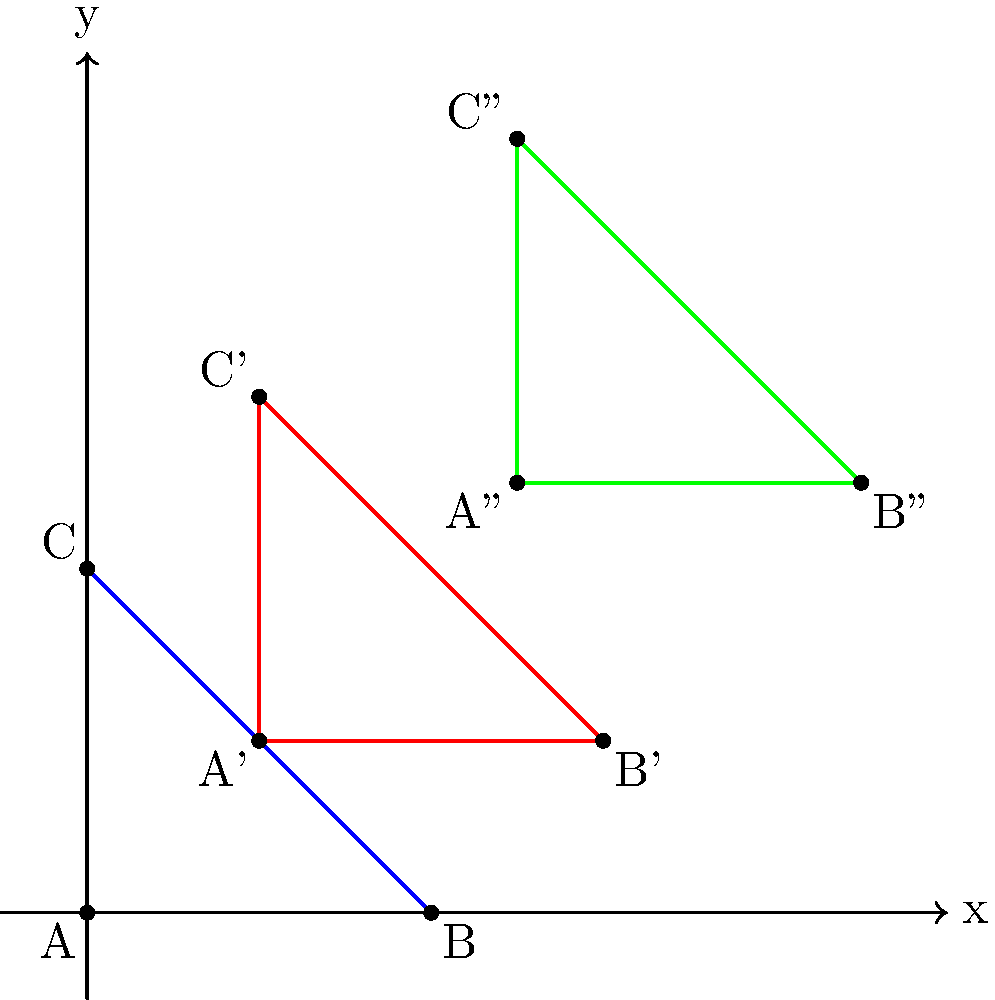On a battlefield map, a unit's position is represented by triangle ABC. The unit undergoes two consecutive transformations: first, a translation of (2,2), followed by a rotation of 90° clockwise around the point (2,2). What are the coordinates of point C after these transformations? Let's approach this step-by-step:

1) Initial position: Triangle ABC has vertices A(0,0), B(4,0), and C(0,4).

2) First transformation - Translation by (2,2):
   - A'(2,2), B'(6,2), C'(2,6)
   This is represented by the red triangle in the diagram.

3) Second transformation - 90° clockwise rotation around (2,2):
   - To rotate a point (x,y) 90° clockwise around (a,b), we use the formula:
     $$(x',y') = (a + (y-b), b - (x-a))$$
   
   - For point C'(2,6), we have:
     $$x'' = 2 + (6-2) = 2 + 4 = 6$$
     $$y'' = 2 - (2-2) = 2 - 0 = 2$$

4) Therefore, after both transformations, point C ends up at C''(6,2).

This is represented by the green triangle in the diagram, where C'' is at (5,5) relative to the original coordinate system.
Answer: (5,5) 